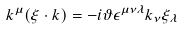Convert formula to latex. <formula><loc_0><loc_0><loc_500><loc_500>k ^ { \mu } ( \xi \cdot k ) = - i \vartheta \epsilon ^ { \mu \nu \lambda } k _ { \nu } \xi _ { \lambda }</formula> 